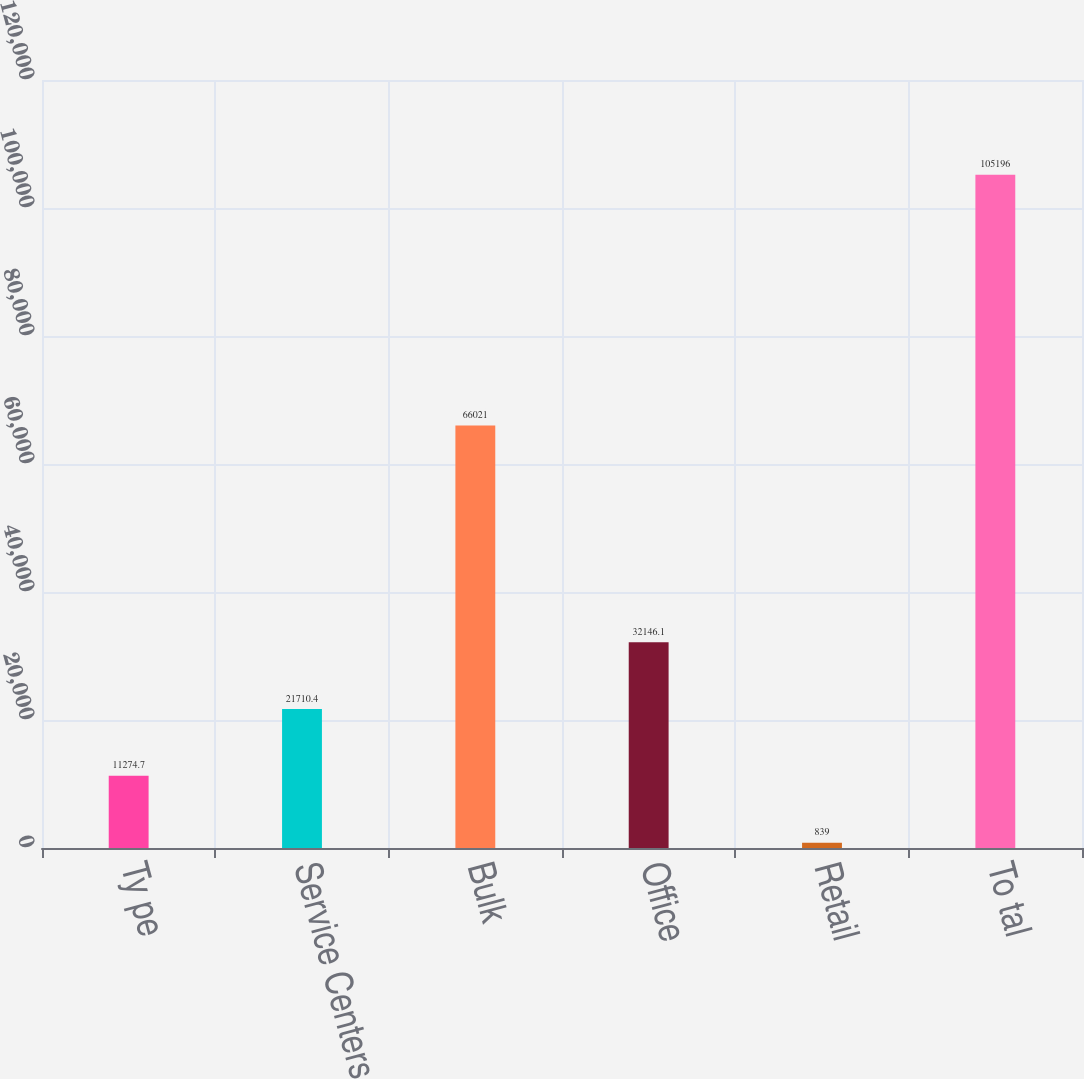Convert chart to OTSL. <chart><loc_0><loc_0><loc_500><loc_500><bar_chart><fcel>Ty pe<fcel>Service Centers<fcel>Bulk<fcel>Office<fcel>Retail<fcel>To tal<nl><fcel>11274.7<fcel>21710.4<fcel>66021<fcel>32146.1<fcel>839<fcel>105196<nl></chart> 